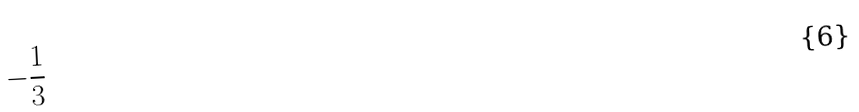Convert formula to latex. <formula><loc_0><loc_0><loc_500><loc_500>- \frac { 1 } { 3 }</formula> 